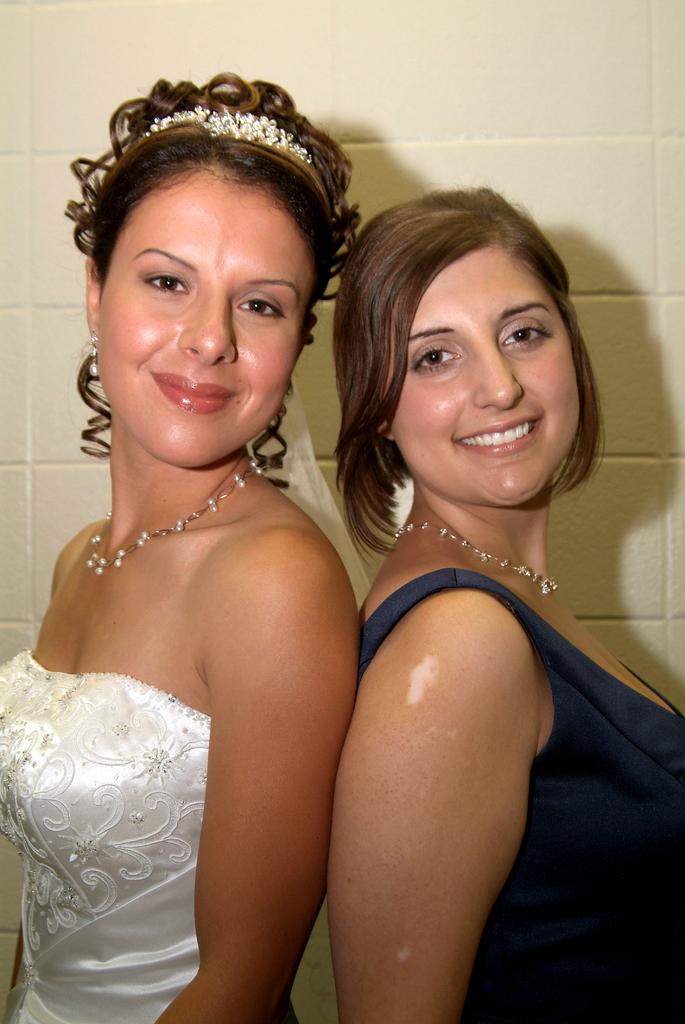How many people are in the image? There are two women in the image. What are the women doing in the image? The women are standing. What can be seen in the background of the image? There is a wall in the image. What type of mark can be seen on the daughter's face in the image? There is no daughter present in the image, and therefore no mark on her face. Where is the park located in the image? There is no park present in the image. 